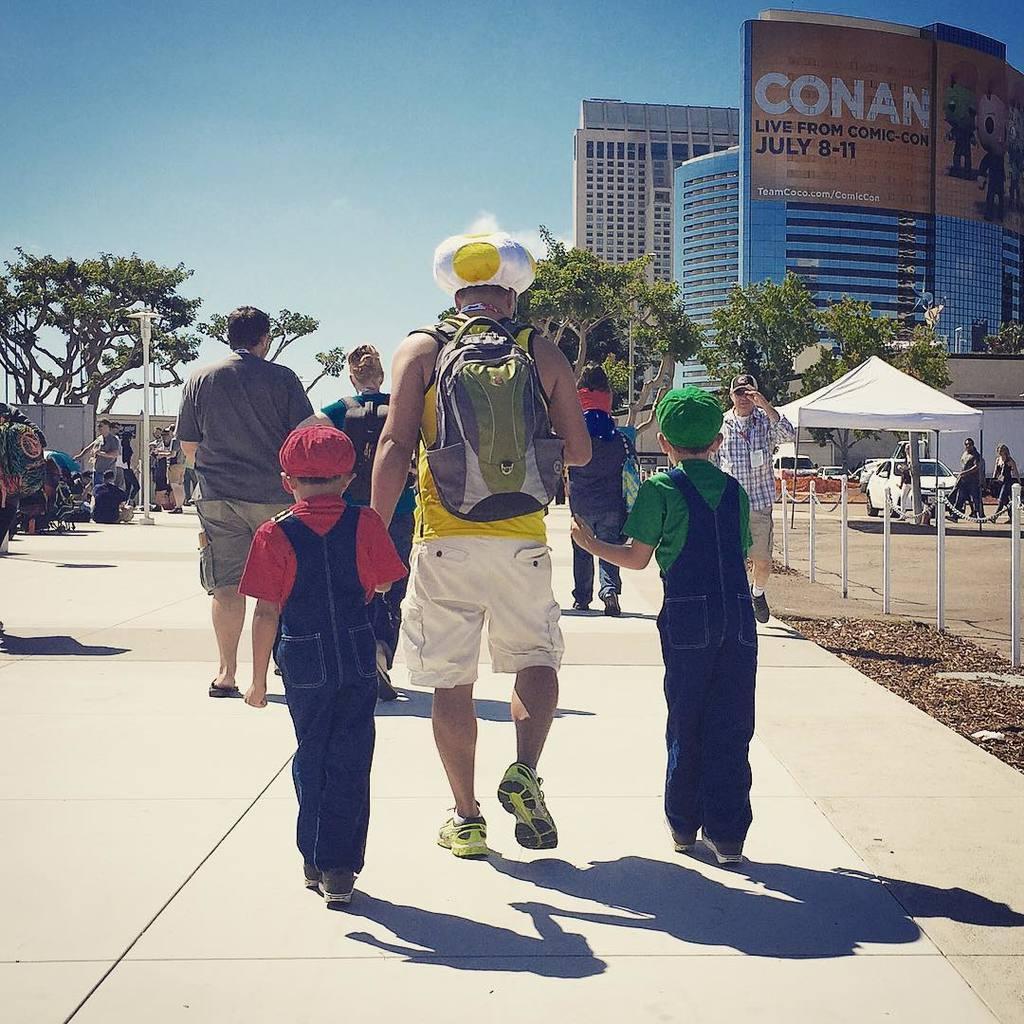How would you summarize this image in a sentence or two? In this picture I can see buildings and a hoarding with text and few cartoons and i can see trees and few people are standing and few are walking and I can see few people wore caps on their heads and tent on the side and few cars parked and a blue cloudy Sky. 